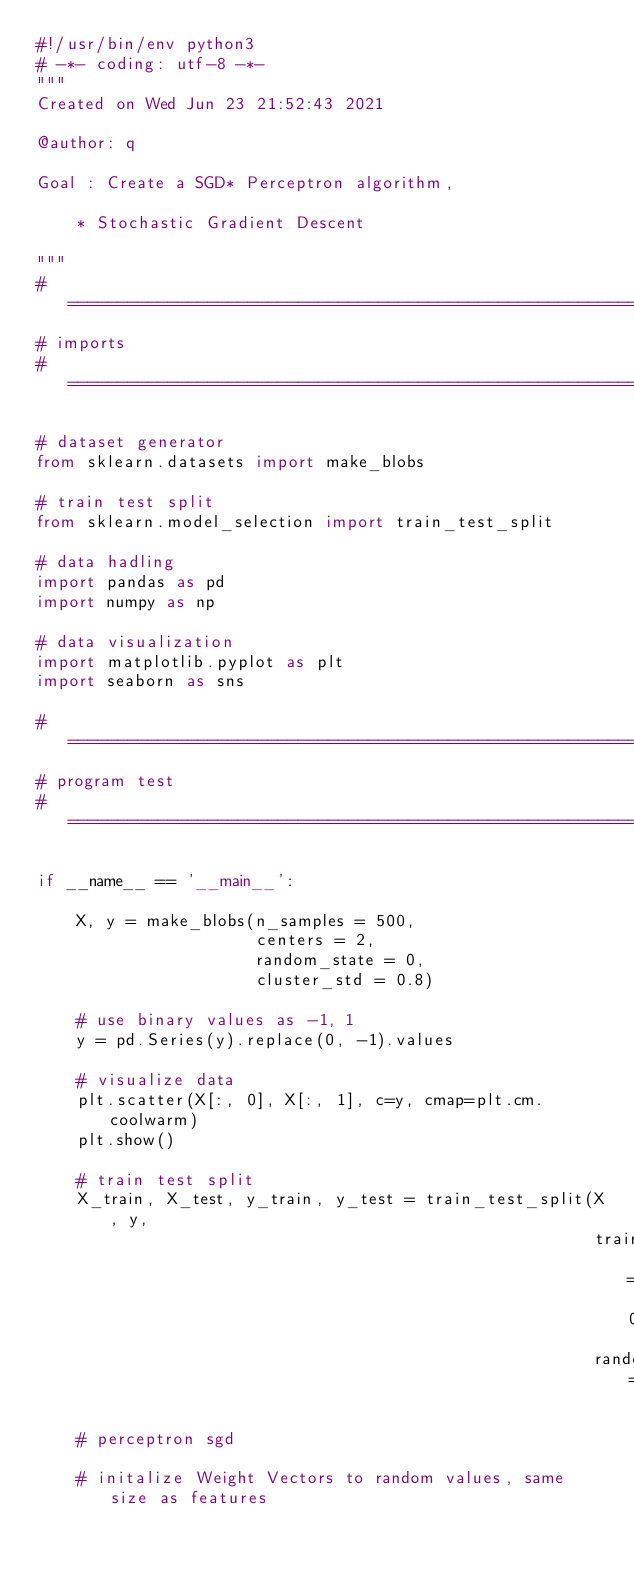Convert code to text. <code><loc_0><loc_0><loc_500><loc_500><_Python_>#!/usr/bin/env python3
# -*- coding: utf-8 -*-
"""
Created on Wed Jun 23 21:52:43 2021

@author: q

Goal : Create a SGD* Perceptron algorithm,
 
    * Stochastic Gradient Descent

"""
# =============================================================================
# imports
# =============================================================================

# dataset generator
from sklearn.datasets import make_blobs

# train test split
from sklearn.model_selection import train_test_split

# data hadling
import pandas as pd
import numpy as np

# data visualization
import matplotlib.pyplot as plt
import seaborn as sns

# =============================================================================
# program test
# =============================================================================

if __name__ == '__main__':
    
    X, y = make_blobs(n_samples = 500, 
                      centers = 2, 
                      random_state = 0, 
                      cluster_std = 0.8)
    
    # use binary values as -1, 1
    y = pd.Series(y).replace(0, -1).values
    
    # visualize data
    plt.scatter(X[:, 0], X[:, 1], c=y, cmap=plt.cm.coolwarm)
    plt.show()

    # train test split
    X_train, X_test, y_train, y_test = train_test_split(X, y, 
                                                        train_size = 0.5, 
                                                        random_state=0)
  
    # perceptron sgd
    
    # initalize Weight Vectors to random values, same size as features</code> 